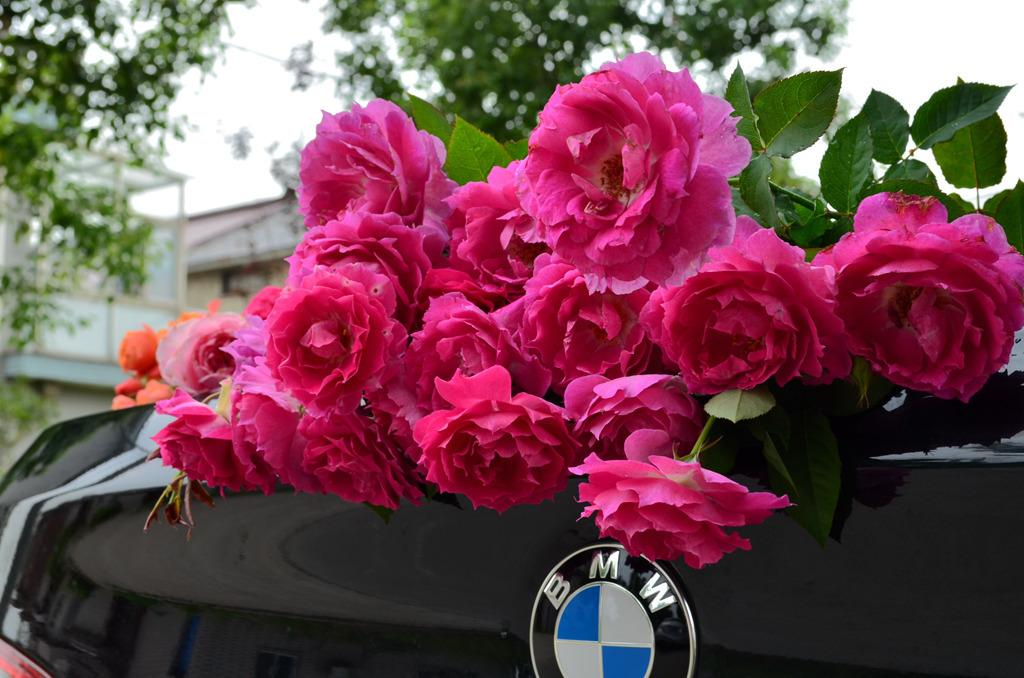What is the main subject of the image? There is a vehicle in the image. What decorative element is present on the vehicle? The vehicle has rose flowers on it. What type of structures can be seen in the image? There are buildings in the image. What type of vegetation is present in the image? There are trees in the image. What can be seen in the background of the image? The sky is visible in the background of the image. What type of vessel is being used for the vacation in the image? There is no vessel or vacation present in the image; it features a vehicle with rose flowers, buildings, trees, and a visible sky. 